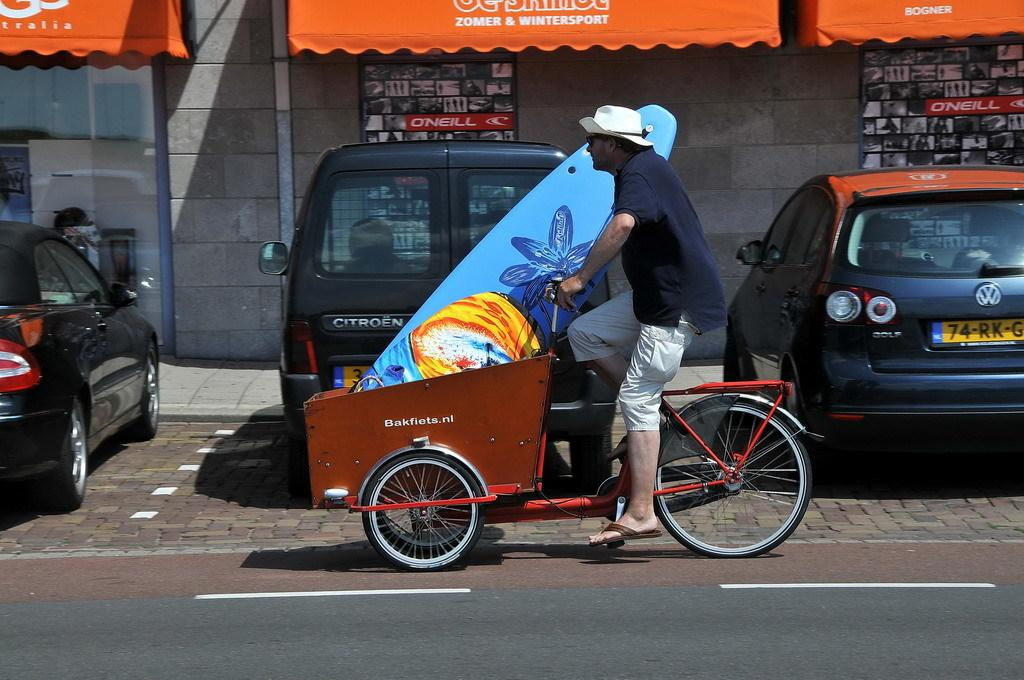What is the main feature of the image? There is a road in the image. What is happening on the road? A man is riding a cycle rickshaw on the road. Are there any vehicles visible in the image? Yes, there are cars in the image. What can be seen in the background of the image? There are shops in the background of the image. What is the purpose of the wall in the image? The wall's purpose is not specified, but it is present in the image. Where is the beggar standing in the image? There is no beggar present in the image. What type of shade is provided by the wall in the image? The wall does not provide any shade in the image, as it is not mentioned to have any overhang or covering. 